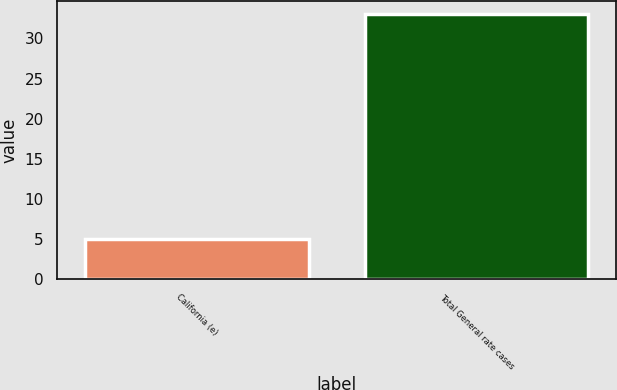<chart> <loc_0><loc_0><loc_500><loc_500><bar_chart><fcel>California (e)<fcel>Total General rate cases<nl><fcel>5<fcel>33<nl></chart> 